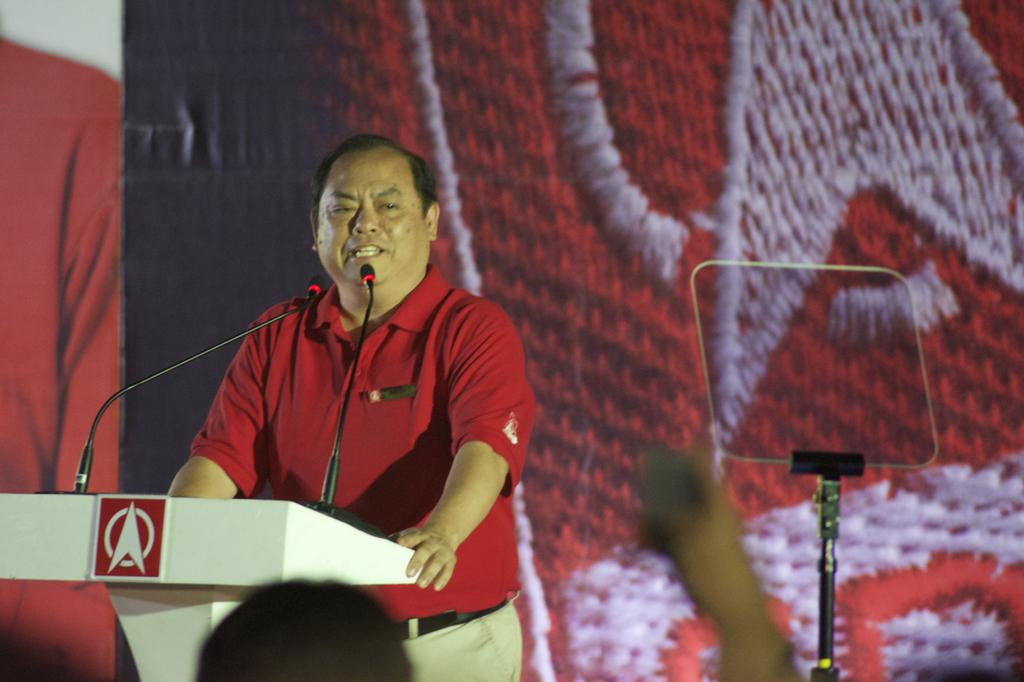What is the person in the image doing? The person is standing in front of a podium. What is on the podium? There are mice on the podium. What can be seen in the background of the image? There is a banner in the background. What is located on the right side of the image? There is a stand on the right side of the image. What type of plot is the writer working on in the image? There is no writer or plot present in the image; it features a person standing in front of a podium with mice on it. Can you tell me what airport is visible in the image? There is no airport visible in the image. 